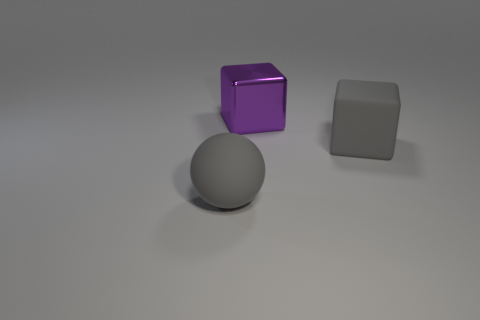What number of gray matte spheres are the same size as the purple metallic cube?
Offer a terse response. 1. What size is the rubber object that is the same color as the matte sphere?
Provide a succinct answer. Large. Is there a shiny ball that has the same color as the large matte block?
Keep it short and to the point. No. What color is the rubber thing that is the same size as the gray ball?
Your response must be concise. Gray. There is a large matte sphere; is its color the same as the large block that is on the left side of the gray block?
Offer a very short reply. No. What color is the big shiny object?
Make the answer very short. Purple. What material is the gray thing to the left of the large purple block?
Offer a very short reply. Rubber. What size is the other thing that is the same shape as the purple metallic thing?
Your answer should be compact. Large. Is the number of purple metal things that are on the left side of the large metal block less than the number of shiny cubes?
Make the answer very short. Yes. Are there any large rubber objects?
Offer a very short reply. Yes. 